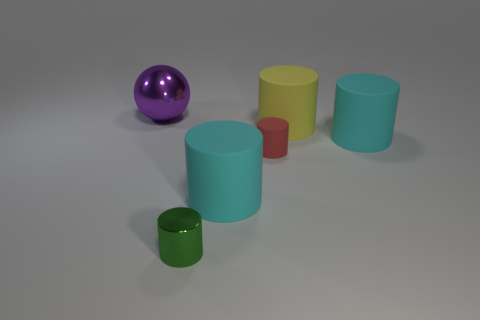What is the color of the cylinder that is both in front of the red rubber object and behind the green shiny object?
Keep it short and to the point. Cyan. What number of cyan objects are the same size as the yellow cylinder?
Make the answer very short. 2. There is a matte cylinder that is both in front of the big yellow matte object and right of the red object; how big is it?
Give a very brief answer. Large. There is a tiny thing to the left of the tiny cylinder that is behind the small green thing; how many tiny cylinders are behind it?
Your answer should be very brief. 1. Is there another small matte thing of the same color as the small matte object?
Your response must be concise. No. There is another object that is the same size as the green metallic thing; what color is it?
Provide a short and direct response. Red. What shape is the metal thing that is behind the tiny cylinder right of the cyan cylinder on the left side of the yellow matte cylinder?
Your answer should be compact. Sphere. What number of cylinders are to the right of the cyan matte thing that is to the left of the big yellow cylinder?
Offer a very short reply. 3. Do the shiny thing in front of the big purple thing and the large cyan matte thing that is to the right of the yellow cylinder have the same shape?
Your answer should be compact. Yes. There is a sphere; how many green things are in front of it?
Offer a very short reply. 1. 